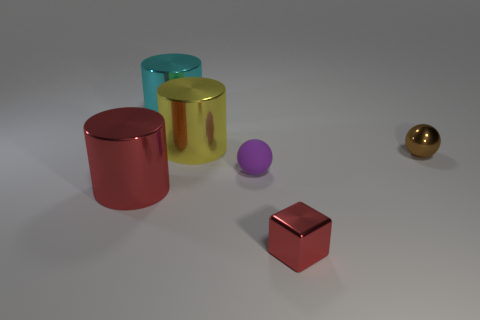Subtract all large yellow cylinders. How many cylinders are left? 2 Subtract all yellow cylinders. How many cylinders are left? 2 Add 2 tiny brown rubber cubes. How many objects exist? 8 Subtract 1 balls. How many balls are left? 1 Subtract all cubes. How many objects are left? 5 Subtract all gray balls. Subtract all purple cylinders. How many balls are left? 2 Subtract all cyan rubber cylinders. Subtract all big yellow objects. How many objects are left? 5 Add 6 large yellow things. How many large yellow things are left? 7 Add 5 small matte balls. How many small matte balls exist? 6 Subtract 0 blue blocks. How many objects are left? 6 